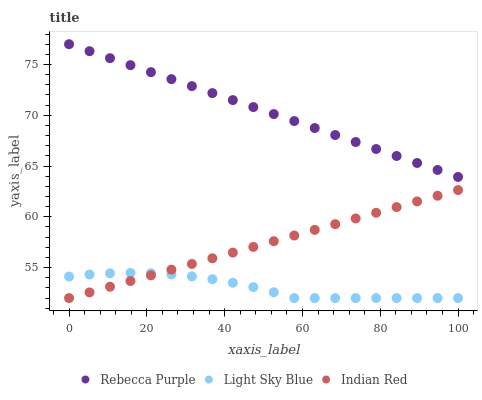Does Light Sky Blue have the minimum area under the curve?
Answer yes or no. Yes. Does Rebecca Purple have the maximum area under the curve?
Answer yes or no. Yes. Does Indian Red have the minimum area under the curve?
Answer yes or no. No. Does Indian Red have the maximum area under the curve?
Answer yes or no. No. Is Indian Red the smoothest?
Answer yes or no. Yes. Is Light Sky Blue the roughest?
Answer yes or no. Yes. Is Rebecca Purple the smoothest?
Answer yes or no. No. Is Rebecca Purple the roughest?
Answer yes or no. No. Does Light Sky Blue have the lowest value?
Answer yes or no. Yes. Does Rebecca Purple have the lowest value?
Answer yes or no. No. Does Rebecca Purple have the highest value?
Answer yes or no. Yes. Does Indian Red have the highest value?
Answer yes or no. No. Is Indian Red less than Rebecca Purple?
Answer yes or no. Yes. Is Rebecca Purple greater than Light Sky Blue?
Answer yes or no. Yes. Does Light Sky Blue intersect Indian Red?
Answer yes or no. Yes. Is Light Sky Blue less than Indian Red?
Answer yes or no. No. Is Light Sky Blue greater than Indian Red?
Answer yes or no. No. Does Indian Red intersect Rebecca Purple?
Answer yes or no. No. 